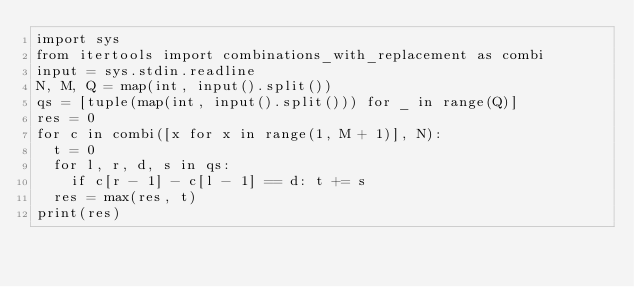<code> <loc_0><loc_0><loc_500><loc_500><_Python_>import sys
from itertools import combinations_with_replacement as combi
input = sys.stdin.readline
N, M, Q = map(int, input().split())
qs = [tuple(map(int, input().split())) for _ in range(Q)]
res = 0
for c in combi([x for x in range(1, M + 1)], N):
  t = 0
  for l, r, d, s in qs:
    if c[r - 1] - c[l - 1] == d: t += s
  res = max(res, t)
print(res)</code> 